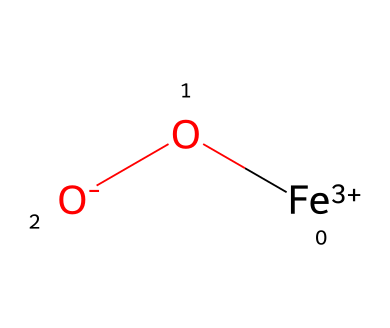What is the oxidation state of iron in the compound? In the provided SMILES representation, [Fe+3] indicates that the iron is in a +3 oxidation state. This is explicitly shown by the "+3" notation adjacent to the iron atom.
Answer: +3 How many oxygen atoms are in the coordination complex? The SMILES representation shows one "O" in the chemical structure, indicating that there is one oxygen atom bonded to the iron ion.
Answer: 1 What type of chemical is represented by this structure? The presence of the iron ion and its bond with oxygen using the coordination sphere suggests that this is a coordination compound, as it has a central metal atom surrounded by ligands (in this case, oxygen).
Answer: coordination compound What is the charge of the complex overall? The iron ion has a +3 charge and is coordinated with an oxygen that has a -2 charge ([O-]), resulting in an overall charge of +1 for the complex when summed together: +3 + (-2) = +1.
Answer: +1 Which component indicates a potential for color in this pigment? The presence of iron in the structure is significant as iron compounds are often responsible for color in pigments, particularly in ochres, where the oxidation states contribute to the varying shades of color.
Answer: iron Is this compound soluble in water? Coordination compounds with metals usually have limited solubility depending on the surrounding ligands. Since there is no information about solubility in the SMILES, it generally indicates poor water solubility for iron oxides.
Answer: poor 